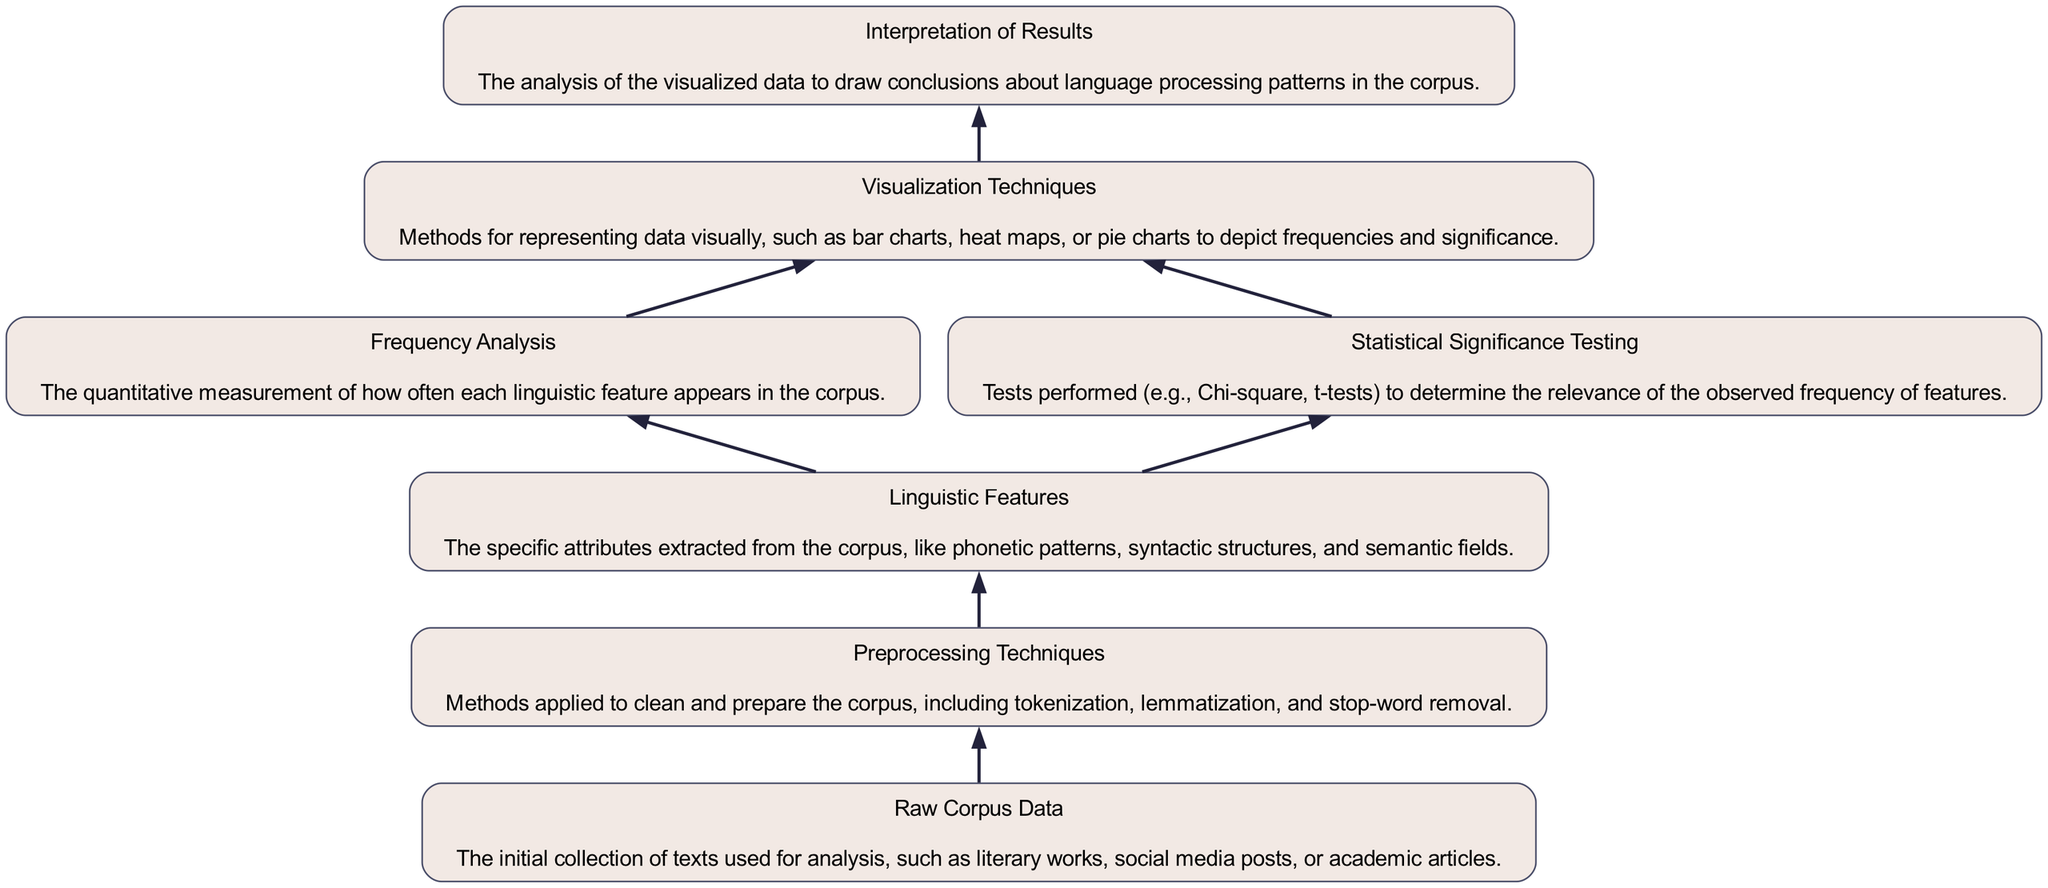What is the first node in the flow chart? The first node in the flow chart represents the "Raw Corpus Data," which is the initial collection of texts used for analysis. It is positioned at the very bottom of the diagram, from which all processes begin.
Answer: Raw Corpus Data How many nodes are present in the flow chart? By counting the nodes starting from "Raw Corpus Data" up to "Interpretation of Results," we find a total of seven nodes present in the flow chart.
Answer: Seven What process follows "Preprocessing Techniques"? The flow of the diagram indicates that after "Preprocessing Techniques," the next process is "Linguistic Features," which is dependent on the completion of preprocessing.
Answer: Linguistic Features Which node has connections to both "Frequency Analysis" and "Statistical Significance Testing"? "Linguistic Features" is the node that connects to both "Frequency Analysis" and "Statistical Significance Testing," indicating that both analyses are based on the features presented in this node.
Answer: Linguistic Features How does "Statistical Significance Testing" relate to the overall flow of the chart? "Statistical Significance Testing" provides an evaluation of the relevance of the features extracted in "Linguistic Features." This relation highlights that statistical tests are a critical part of determining the significance of the analyzed data before visualization.
Answer: It evaluates relevance What is the last step in the flow chart? The flow chart concludes with the "Interpretation of Results," which signifies that all the studies performed culminate in this step for drawing conclusions about language processing.
Answer: Interpretation of Results How many edges are there in this diagram? By counting the directed connections between the nodes, we can see there are six edges that connect all the nodes in the flow of the analysis.
Answer: Six Which two processes occur simultaneously after "Linguistic Features"? After "Linguistic Features," the two processes that occur simultaneously are "Frequency Analysis" and "Statistical Significance Testing," both branching out from the same node.
Answer: Frequency Analysis and Statistical Significance Testing 